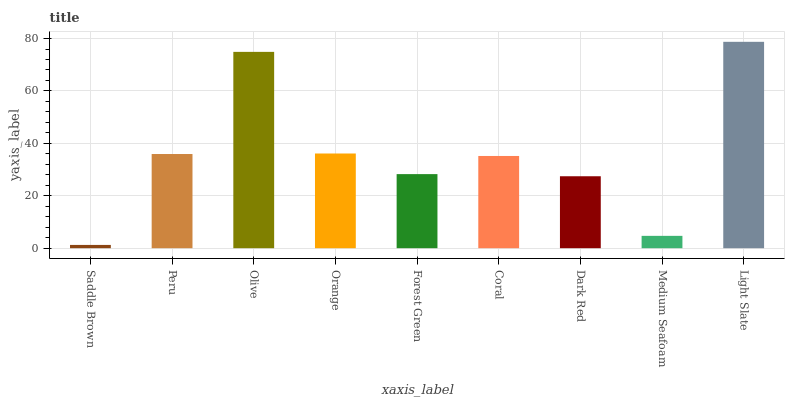Is Saddle Brown the minimum?
Answer yes or no. Yes. Is Light Slate the maximum?
Answer yes or no. Yes. Is Peru the minimum?
Answer yes or no. No. Is Peru the maximum?
Answer yes or no. No. Is Peru greater than Saddle Brown?
Answer yes or no. Yes. Is Saddle Brown less than Peru?
Answer yes or no. Yes. Is Saddle Brown greater than Peru?
Answer yes or no. No. Is Peru less than Saddle Brown?
Answer yes or no. No. Is Coral the high median?
Answer yes or no. Yes. Is Coral the low median?
Answer yes or no. Yes. Is Olive the high median?
Answer yes or no. No. Is Forest Green the low median?
Answer yes or no. No. 